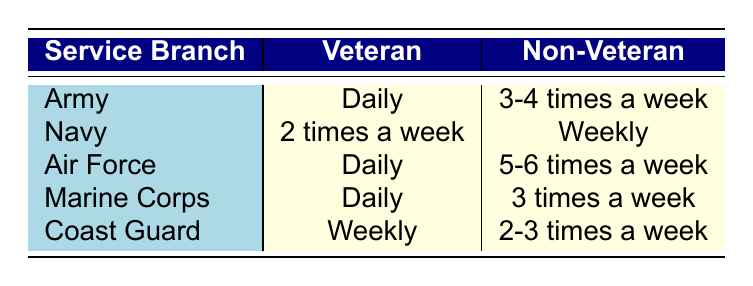What is the workout frequency for Veterans in the Army? The table shows the Army's workout frequency for Veterans as "Daily."
Answer: Daily How often do Non-Veterans in the Navy work out? According to the table, Non-Veterans in the Navy work out "Weekly."
Answer: Weekly Which service branch has the highest workout frequency among Veterans? The table indicates that all Veterans in the Army, Air Force, and Marine Corps work out "Daily." Therefore, there are multiple service branches with the highest frequency, which are Army, Air Force, and Marine Corps.
Answer: Army, Air Force, and Marine Corps How many service branches have Non-Veterans working out 3 times a week? The table shows that the Marine Corps is the only service branch where Non-Veterans work out "3 times a week."
Answer: 1 Is it true that Veterans in the Coast Guard work out "Daily"? The table specifies that Veterans in the Coast Guard work out "Weekly," hence the statement is false.
Answer: No What is the difference in workout frequency between the Non-Veterans in the Air Force and those in the Navy? Non-Veterans in the Air Force work out "5-6 times a week," while Non-Veterans in the Navy work out "Weekly." Since "5-6 times a week" indicates a higher frequency than "Weekly," the difference is in favor of the Air Force.
Answer: Air Force has higher frequency Which service branch has both Veterans and Non-Veterans working out daily? The table indicates that only the Army, Air Force, and Marine Corps have Veterans that work out daily; however, only the Army and Marine Corps have Non-Veterans whose frequency matches the Veterans' daily workout. Hence, only the Army and Marine Corps meet this criterion.
Answer: Army and Marine Corps If we look at the average workout frequency of all the branches listed for veterans, how many work out daily? The table lists three service branches (Army, Air Force, Marine Corps) that have Veterans working out "Daily," so the count is three.
Answer: 3 Are there any service branches where Non-Veterans work out more frequently than Veterans? The table shows that Non-Veterans in the Air Force ("5-6 times a week") do work out more frequently than Veterans in the Coast Guard ("Weekly"). Hence, the answer is yes.
Answer: Yes 